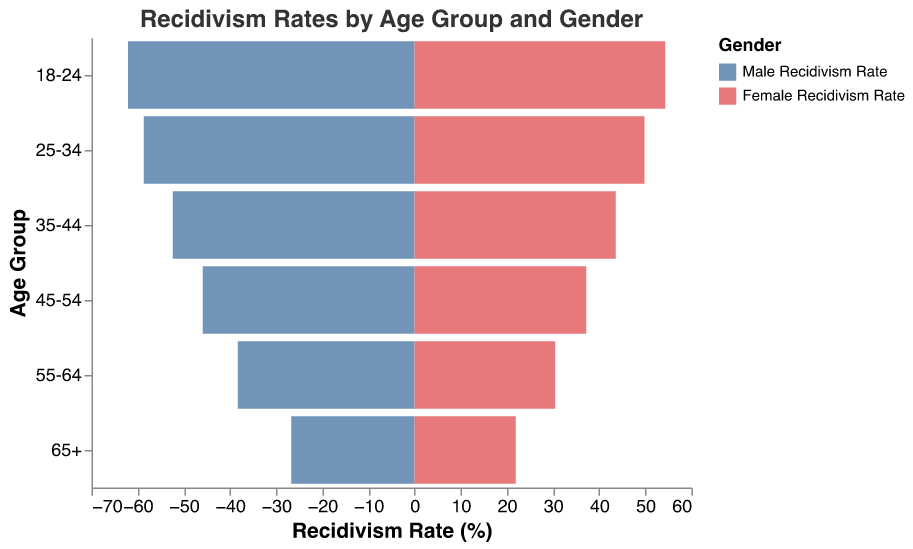What is the title of the figure? The title is displayed at the top of the figure and reads "Recidivism Rates by Age Group and Gender".
Answer: Recidivism Rates by Age Group and Gender How many age groups are displayed in the figure? The y-axis lists all age groups: 18-24, 25-34, 35-44, 45-54, 55-64, and 65+, which totals to 6 age groups.
Answer: 6 What is the recidivism rate for males in the 25-34 age group? According to the data values displayed in the bars near the y-axis labeled "25-34", the male recidivism rate is 58.7%.
Answer: 58.7% Which age group has the lowest recidivism rate for females? By comparing all female recidivism rates from the bars in each age group, the age group 65+ has the lowest rate at 21.9%.
Answer: 65+ How do the recidivism rates for males and females compare in the 45-54 age group? By looking at the bars for the 45-54 age group, the male recidivism rate is 45.9%, and the female recidivism rate is 37.2%. Hence, males have a higher rate than females in this age group.
Answer: Males have a higher rate Compare the recidivism rates between the youngest (18-24) and oldest (65+) age groups for both genders. For 18-24, males have a rate of 62.1% and females 54.3%. For 65+, males have a rate of 26.7% and females 21.9%. The rates are significantly higher for both genders in the 18-24 group compared to the 65+ group.
Answer: Higher for 18-24 Which gender shows a greater overall reduction in recidivism rates from the youngest to the oldest age group? For males, the reduction is 62.1% - 26.7% = 35.4%. For females, the reduction is 54.3% - 21.9% = 32.4%. Male recidivism rates show a greater reduction.
Answer: Males Is there an age group where the difference in recidivism rates between genders is the smallest? The age group 65+ shows the smallest difference, where the recidivism rates are 26.7% for males and 21.9% for females, resulting in a difference of 4.8%.
Answer: 65+ What is the average recidivism rate for males across all age groups? Adding all male recidivism rates: 62.1 + 58.7 + 52.4 + 45.9 + 38.3 + 26.7 = 284.1. Dividing by the number of age groups, 284.1 / 6 = 47.35%.
Answer: 47.35% How does the average recidivism rate for females compare to that for males? Calculating the female average: (54.3 + 49.8 + 43.6 + 37.2 + 30.5 + 21.9)/6 = 39.55%. Compared to the male average of 47.35%, the female average is lower.
Answer: Lower for females 